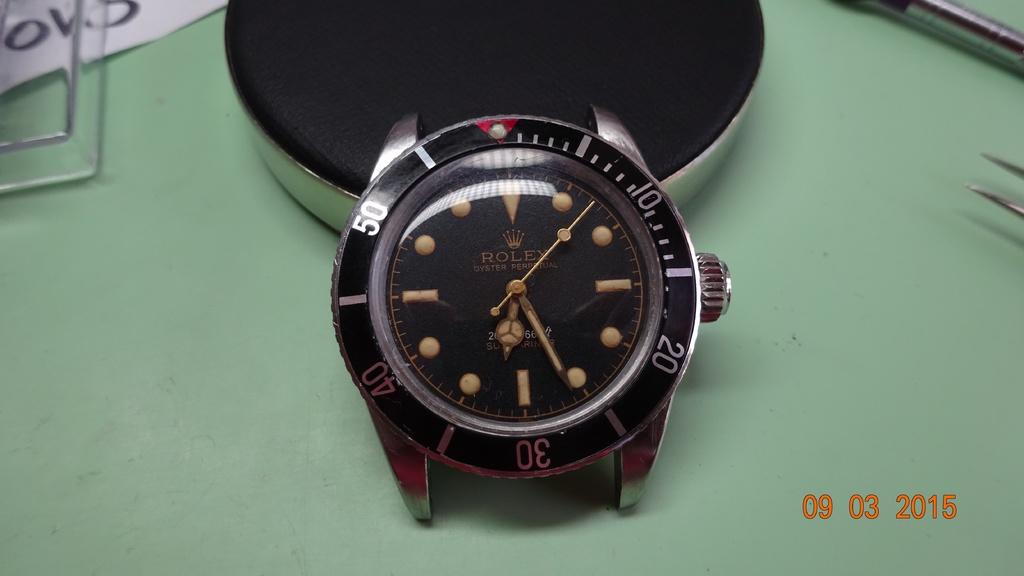What brand of watch is this?
Your answer should be very brief. Rolex. When was this picture taken?
Provide a succinct answer. 09 03 2015. 